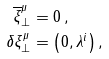<formula> <loc_0><loc_0><loc_500><loc_500>\overline { \xi } _ { \perp } ^ { \mu } & = 0 \, , \\ \delta \xi _ { \perp } ^ { \mu } & = \left ( 0 , \lambda ^ { i } \right ) ,</formula> 